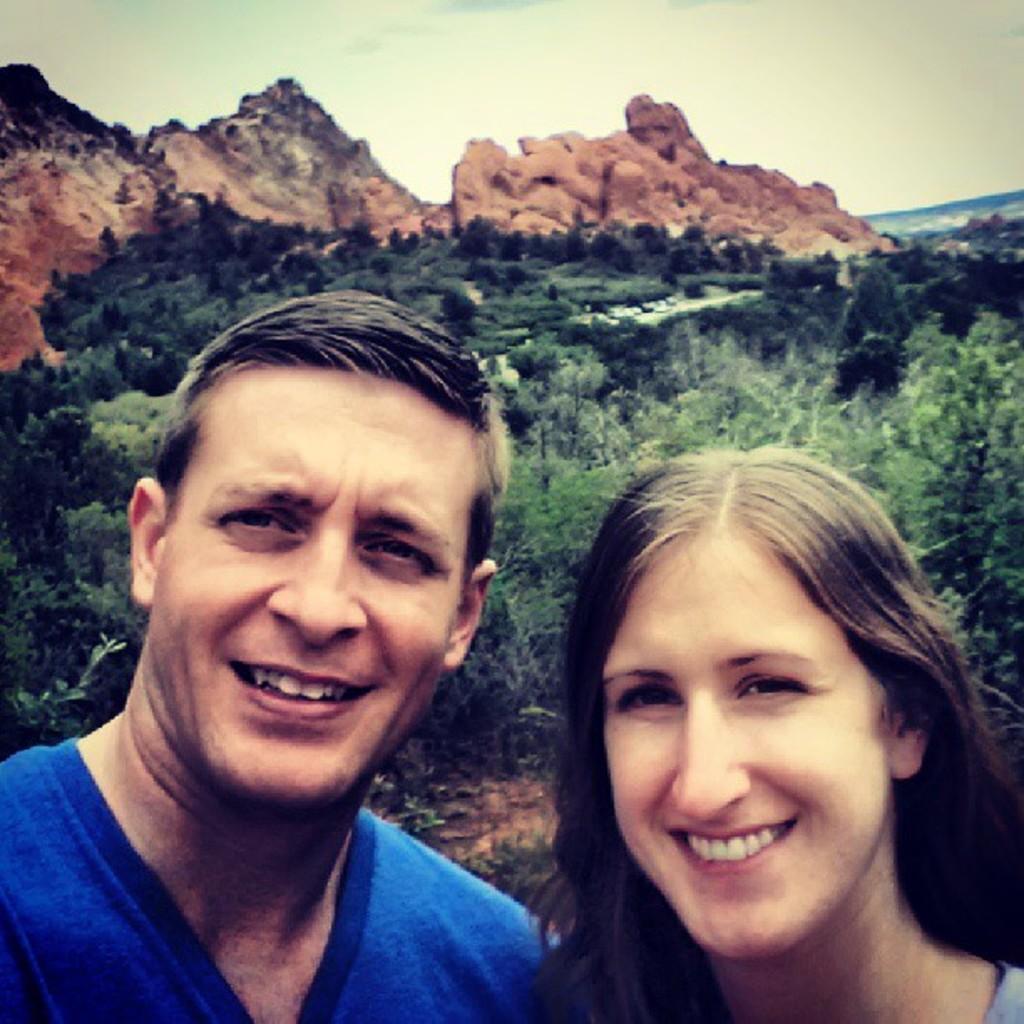Could you give a brief overview of what you see in this image? In this image I can see a man and a woman are smiling. In the background I can see trees, mountain and the sky. 